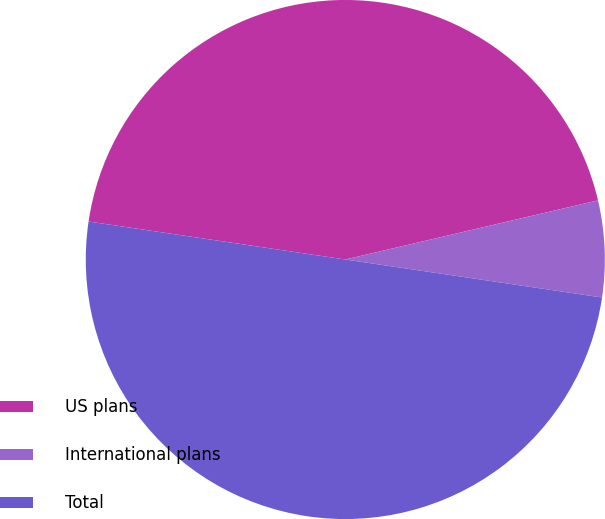<chart> <loc_0><loc_0><loc_500><loc_500><pie_chart><fcel>US plans<fcel>International plans<fcel>Total<nl><fcel>44.0%<fcel>6.0%<fcel>50.0%<nl></chart> 